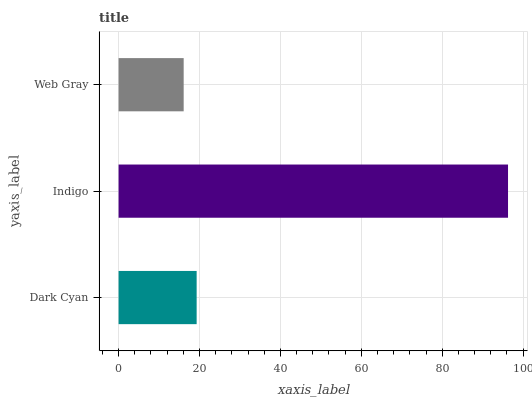Is Web Gray the minimum?
Answer yes or no. Yes. Is Indigo the maximum?
Answer yes or no. Yes. Is Indigo the minimum?
Answer yes or no. No. Is Web Gray the maximum?
Answer yes or no. No. Is Indigo greater than Web Gray?
Answer yes or no. Yes. Is Web Gray less than Indigo?
Answer yes or no. Yes. Is Web Gray greater than Indigo?
Answer yes or no. No. Is Indigo less than Web Gray?
Answer yes or no. No. Is Dark Cyan the high median?
Answer yes or no. Yes. Is Dark Cyan the low median?
Answer yes or no. Yes. Is Web Gray the high median?
Answer yes or no. No. Is Web Gray the low median?
Answer yes or no. No. 